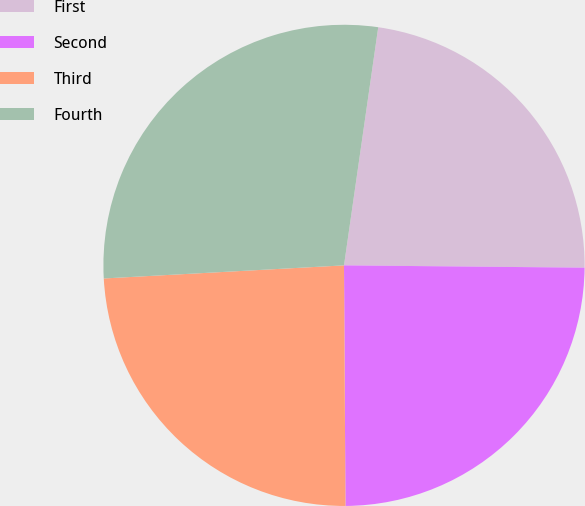<chart> <loc_0><loc_0><loc_500><loc_500><pie_chart><fcel>First<fcel>Second<fcel>Third<fcel>Fourth<nl><fcel>22.88%<fcel>24.75%<fcel>24.23%<fcel>28.14%<nl></chart> 